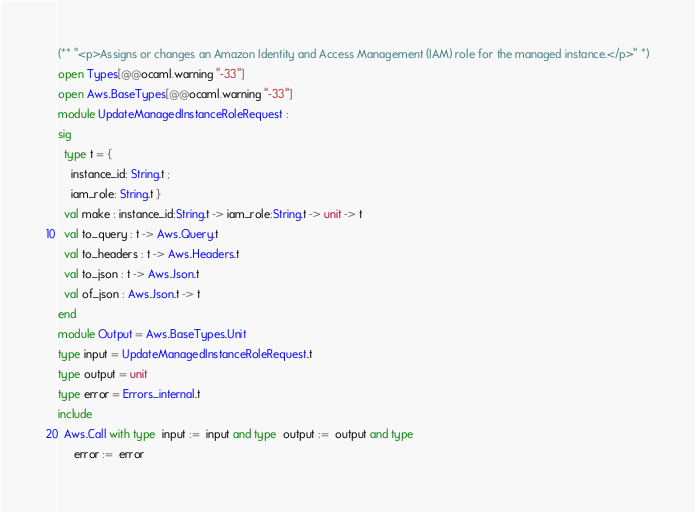Convert code to text. <code><loc_0><loc_0><loc_500><loc_500><_OCaml_>(** "<p>Assigns or changes an Amazon Identity and Access Management (IAM) role for the managed instance.</p>" *)
open Types[@@ocaml.warning "-33"]
open Aws.BaseTypes[@@ocaml.warning "-33"]
module UpdateManagedInstanceRoleRequest :
sig
  type t = {
    instance_id: String.t ;
    iam_role: String.t }
  val make : instance_id:String.t -> iam_role:String.t -> unit -> t
  val to_query : t -> Aws.Query.t
  val to_headers : t -> Aws.Headers.t
  val to_json : t -> Aws.Json.t
  val of_json : Aws.Json.t -> t
end
module Output = Aws.BaseTypes.Unit
type input = UpdateManagedInstanceRoleRequest.t
type output = unit
type error = Errors_internal.t
include
  Aws.Call with type  input :=  input and type  output :=  output and type
     error :=  error</code> 